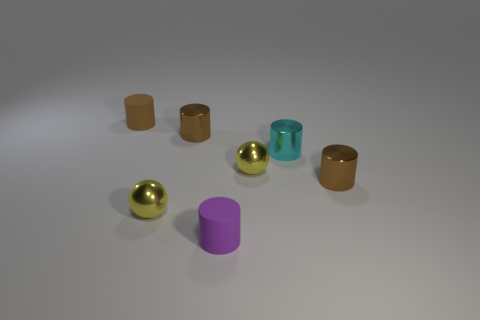Subtract all cyan metal cylinders. How many cylinders are left? 4 Add 1 yellow cubes. How many objects exist? 8 Subtract all spheres. How many objects are left? 5 Subtract all purple cylinders. How many cylinders are left? 4 Subtract 0 gray cylinders. How many objects are left? 7 Subtract 2 spheres. How many spheres are left? 0 Subtract all green spheres. Subtract all purple blocks. How many spheres are left? 2 Subtract all purple spheres. How many cyan cylinders are left? 1 Subtract all small cyan cylinders. Subtract all metallic objects. How many objects are left? 1 Add 7 purple cylinders. How many purple cylinders are left? 8 